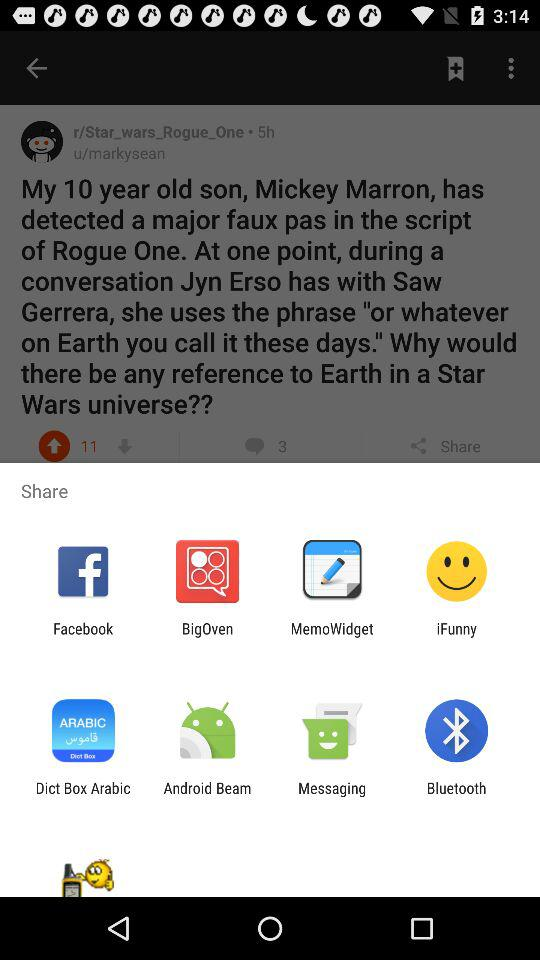How many comments are received? There are 3 comments received. 